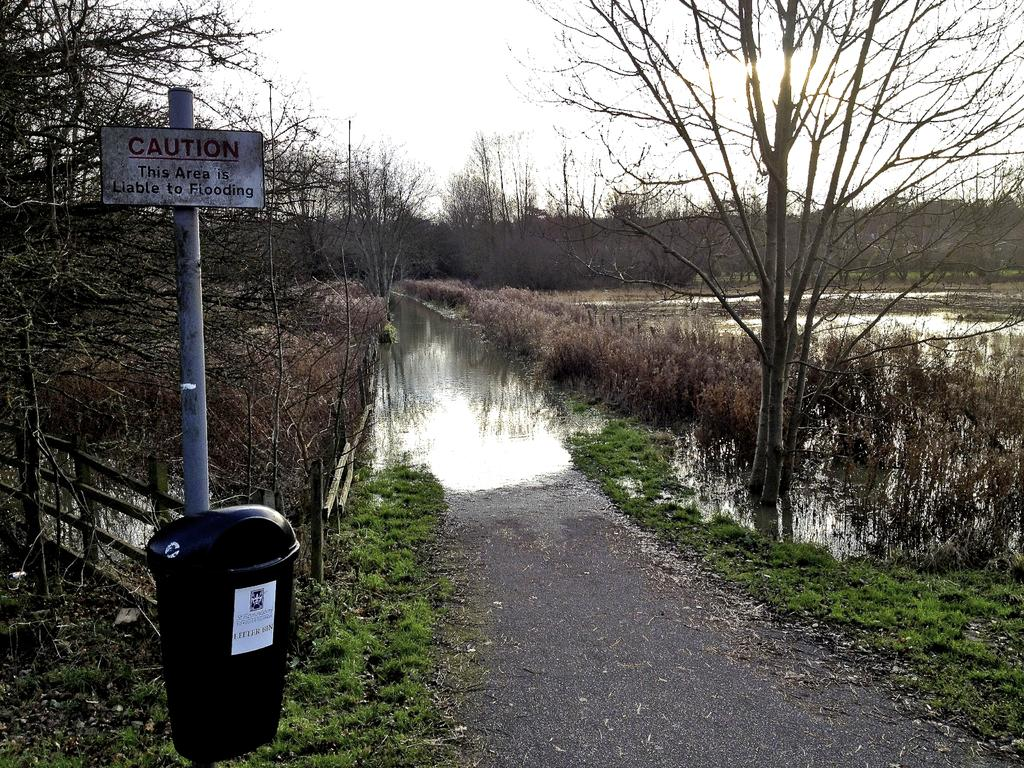<image>
Render a clear and concise summary of the photo. Black garbage can under a sign which says CAUTION. 